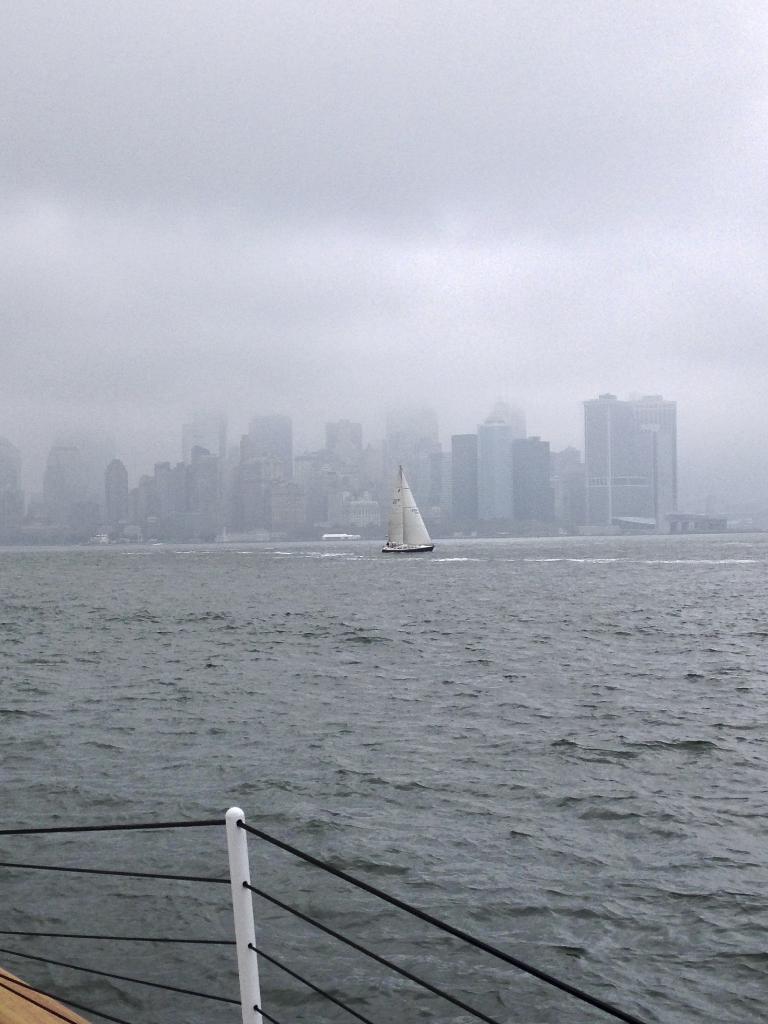Describe this image in one or two sentences. In this picture we can see water at the bottom, there is a boat in the middle, in the background we can see buildings, there is the sky at the top of the picture. 